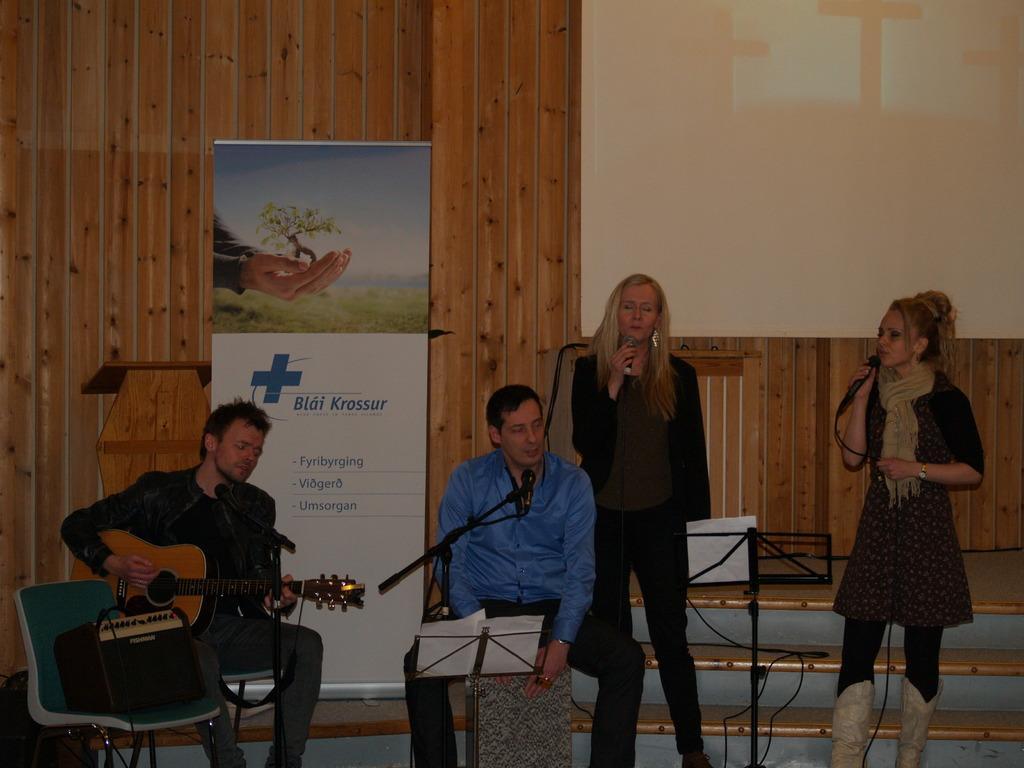Please provide a concise description of this image. There are four persons. The two persons are standing on the right side. They are holding a mic and singing a song. The other two persons are sitting on a chairs. They are playing a musical instruments. We can see in the background poster ,board and wooden wall. 